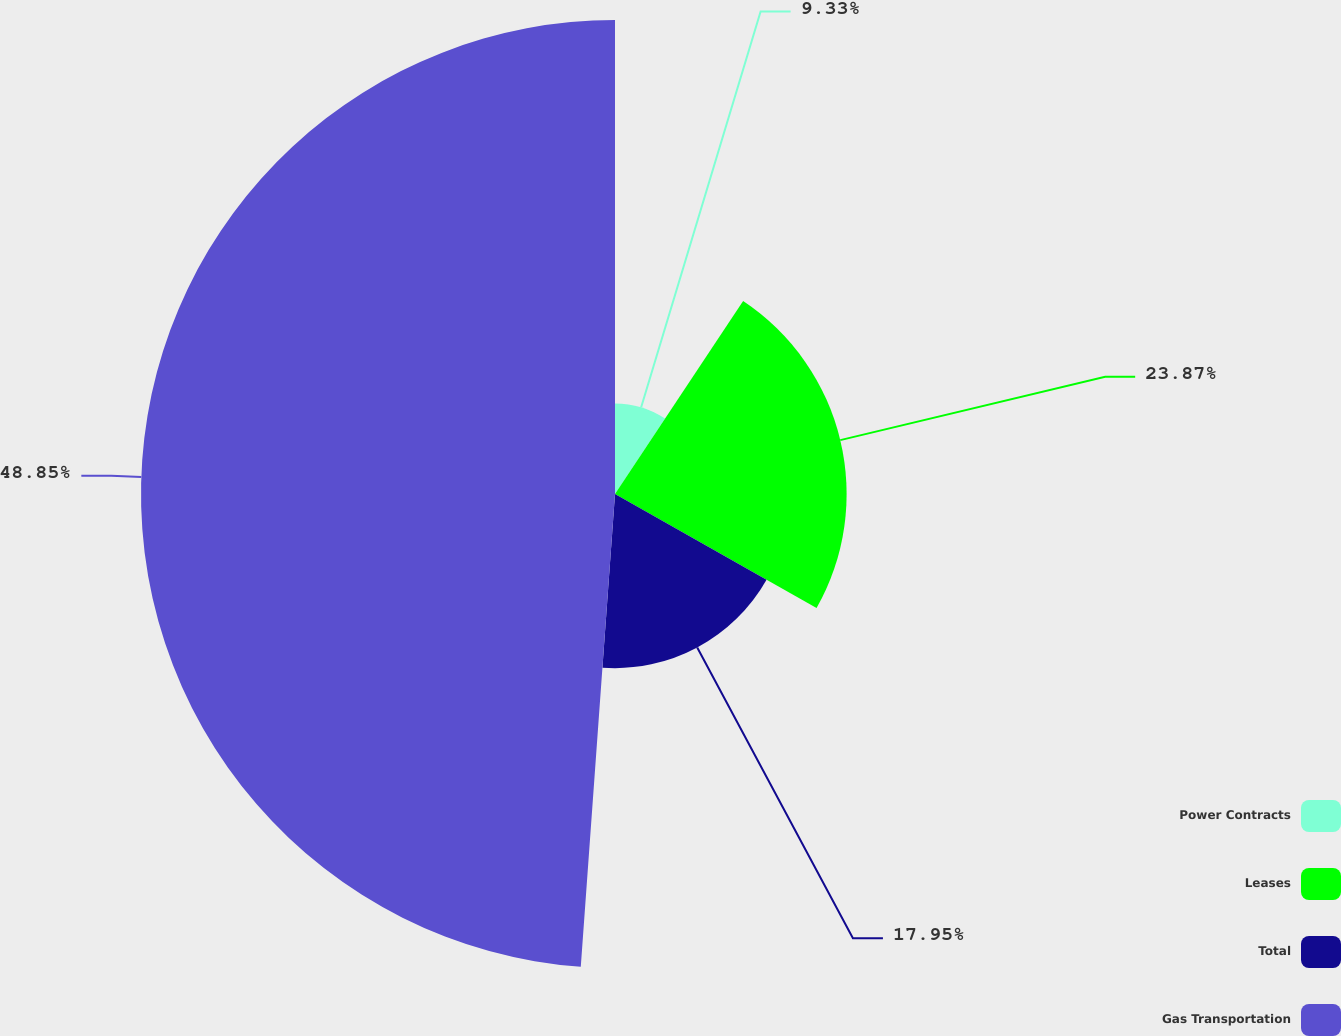Convert chart to OTSL. <chart><loc_0><loc_0><loc_500><loc_500><pie_chart><fcel>Power Contracts<fcel>Leases<fcel>Total<fcel>Gas Transportation<nl><fcel>9.33%<fcel>23.87%<fcel>17.95%<fcel>48.85%<nl></chart> 